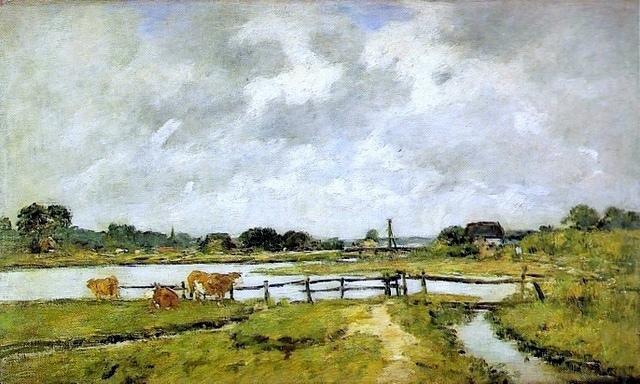Do the clouds look stormy?
Be succinct. Yes. What type of animals are pictured?
Short answer required. Cows. How many animals is in this painting?
Concise answer only. 3. 